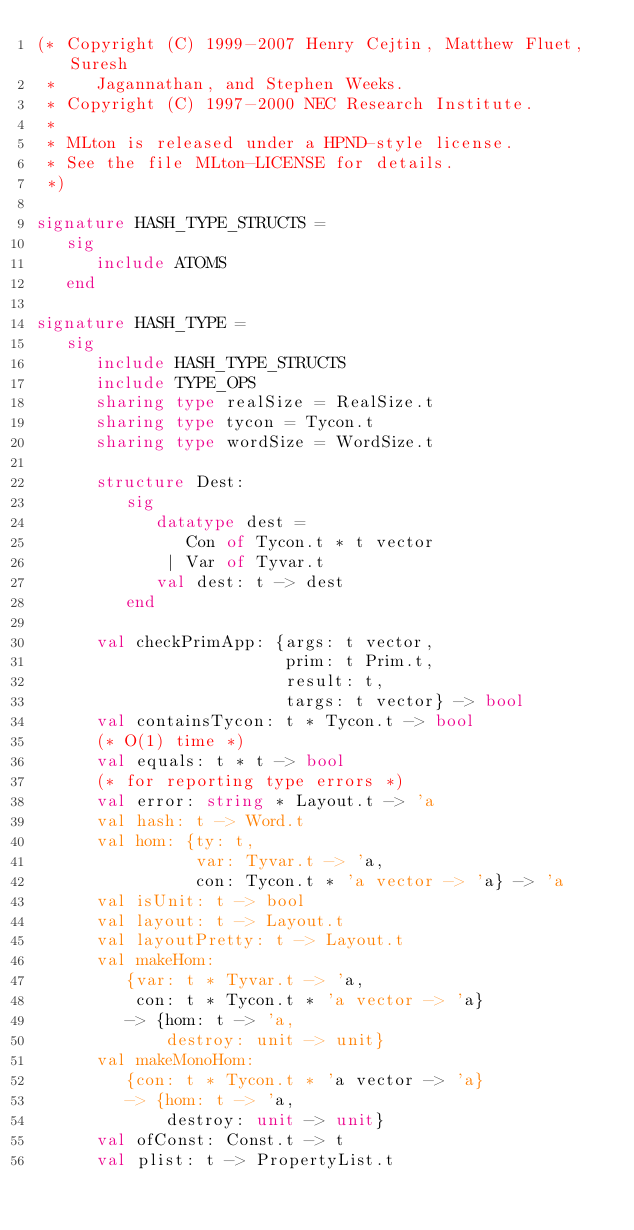Convert code to text. <code><loc_0><loc_0><loc_500><loc_500><_SML_>(* Copyright (C) 1999-2007 Henry Cejtin, Matthew Fluet, Suresh
 *    Jagannathan, and Stephen Weeks.
 * Copyright (C) 1997-2000 NEC Research Institute.
 *
 * MLton is released under a HPND-style license.
 * See the file MLton-LICENSE for details.
 *)

signature HASH_TYPE_STRUCTS = 
   sig
      include ATOMS
   end

signature HASH_TYPE = 
   sig
      include HASH_TYPE_STRUCTS
      include TYPE_OPS
      sharing type realSize = RealSize.t
      sharing type tycon = Tycon.t
      sharing type wordSize = WordSize.t

      structure Dest:
         sig
            datatype dest =
               Con of Tycon.t * t vector
             | Var of Tyvar.t
            val dest: t -> dest
         end

      val checkPrimApp: {args: t vector,
                         prim: t Prim.t,
                         result: t,
                         targs: t vector} -> bool
      val containsTycon: t * Tycon.t -> bool
      (* O(1) time *)
      val equals: t * t -> bool
      (* for reporting type errors *)
      val error: string * Layout.t -> 'a
      val hash: t -> Word.t
      val hom: {ty: t,
                var: Tyvar.t -> 'a,
                con: Tycon.t * 'a vector -> 'a} -> 'a
      val isUnit: t -> bool
      val layout: t -> Layout.t
      val layoutPretty: t -> Layout.t
      val makeHom:
         {var: t * Tyvar.t -> 'a,
          con: t * Tycon.t * 'a vector -> 'a}
         -> {hom: t -> 'a,
             destroy: unit -> unit}
      val makeMonoHom:
         {con: t * Tycon.t * 'a vector -> 'a}
         -> {hom: t -> 'a,
             destroy: unit -> unit}
      val ofConst: Const.t -> t
      val plist: t -> PropertyList.t</code> 